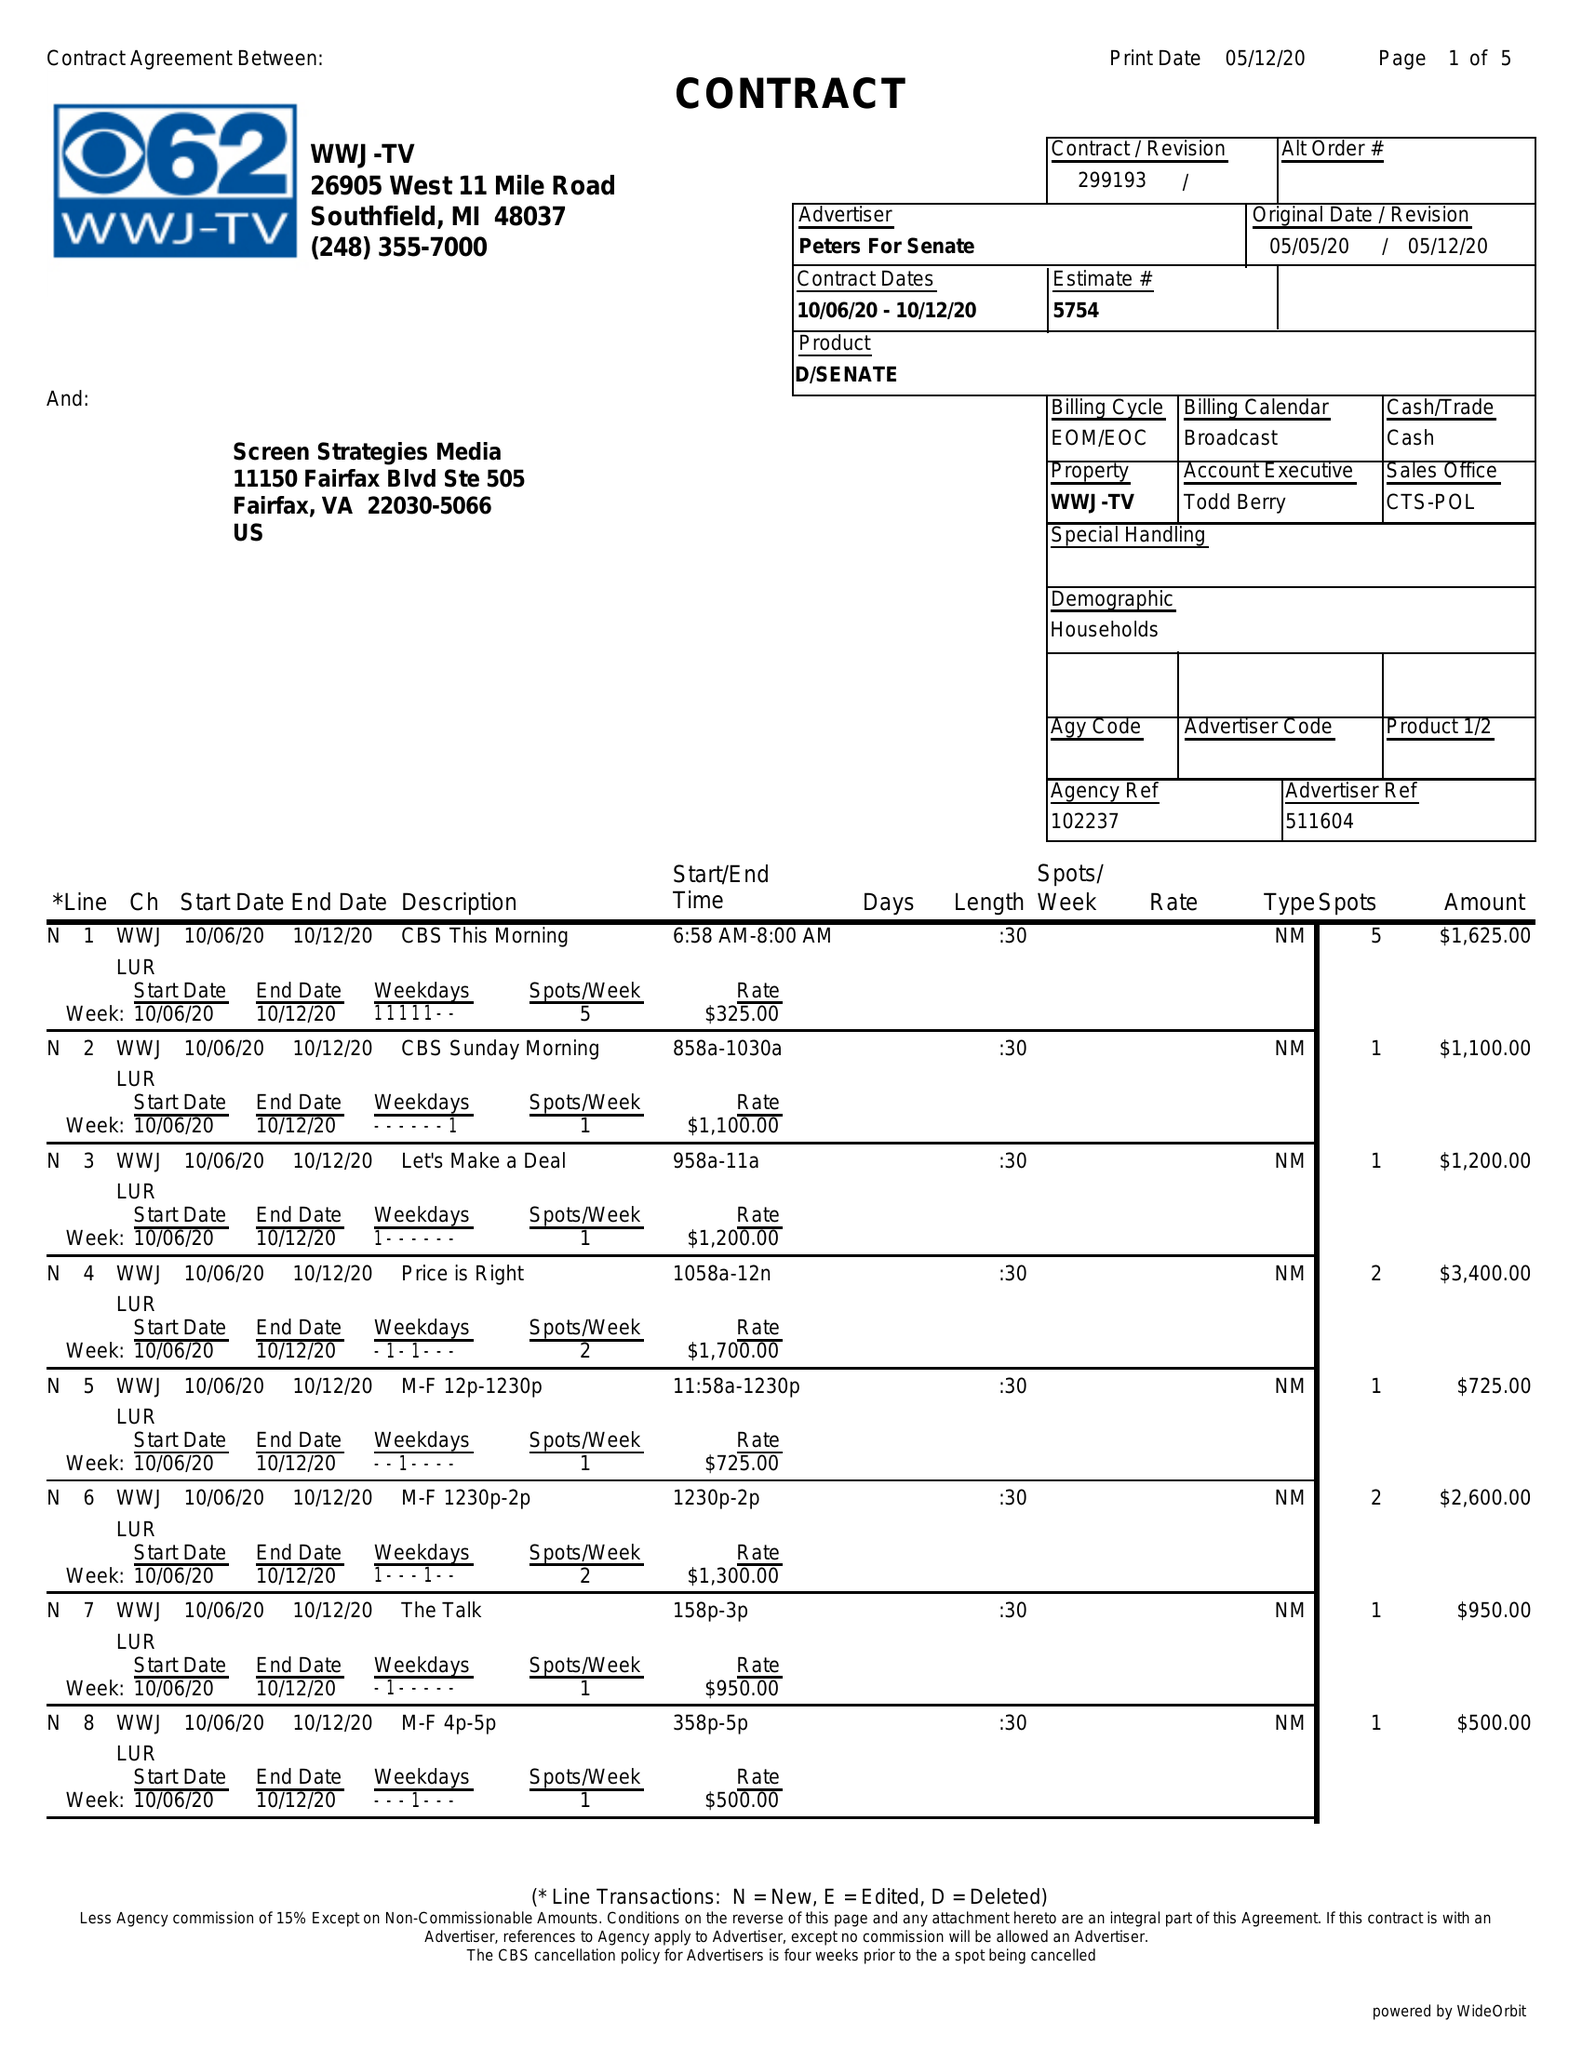What is the value for the gross_amount?
Answer the question using a single word or phrase. 94700.00 